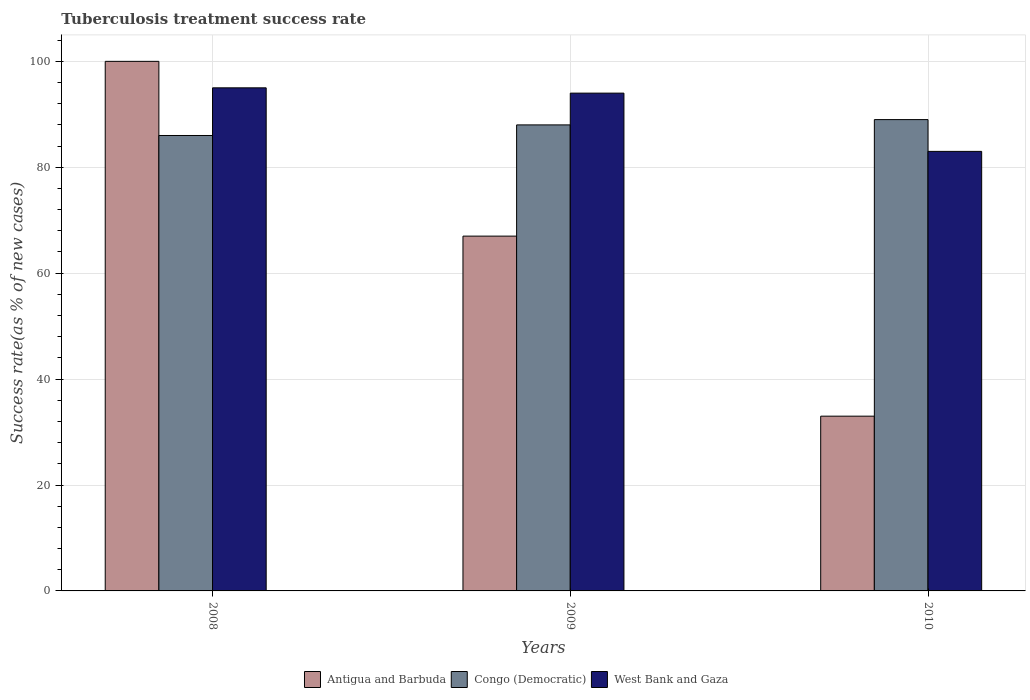How many different coloured bars are there?
Make the answer very short. 3. How many groups of bars are there?
Your response must be concise. 3. How many bars are there on the 2nd tick from the right?
Your response must be concise. 3. What is the tuberculosis treatment success rate in Antigua and Barbuda in 2008?
Give a very brief answer. 100. Across all years, what is the maximum tuberculosis treatment success rate in West Bank and Gaza?
Make the answer very short. 95. In which year was the tuberculosis treatment success rate in West Bank and Gaza maximum?
Ensure brevity in your answer.  2008. What is the total tuberculosis treatment success rate in West Bank and Gaza in the graph?
Keep it short and to the point. 272. What is the difference between the tuberculosis treatment success rate in West Bank and Gaza in 2008 and the tuberculosis treatment success rate in Congo (Democratic) in 2010?
Offer a terse response. 6. What is the average tuberculosis treatment success rate in Congo (Democratic) per year?
Provide a short and direct response. 87.67. In the year 2009, what is the difference between the tuberculosis treatment success rate in Antigua and Barbuda and tuberculosis treatment success rate in Congo (Democratic)?
Make the answer very short. -21. In how many years, is the tuberculosis treatment success rate in Congo (Democratic) greater than 76 %?
Keep it short and to the point. 3. What is the ratio of the tuberculosis treatment success rate in West Bank and Gaza in 2009 to that in 2010?
Keep it short and to the point. 1.13. Is the tuberculosis treatment success rate in Congo (Democratic) in 2008 less than that in 2010?
Give a very brief answer. Yes. Is the difference between the tuberculosis treatment success rate in Antigua and Barbuda in 2009 and 2010 greater than the difference between the tuberculosis treatment success rate in Congo (Democratic) in 2009 and 2010?
Keep it short and to the point. Yes. What is the difference between the highest and the second highest tuberculosis treatment success rate in West Bank and Gaza?
Give a very brief answer. 1. What is the difference between the highest and the lowest tuberculosis treatment success rate in Congo (Democratic)?
Keep it short and to the point. 3. Is the sum of the tuberculosis treatment success rate in West Bank and Gaza in 2008 and 2010 greater than the maximum tuberculosis treatment success rate in Antigua and Barbuda across all years?
Make the answer very short. Yes. What does the 1st bar from the left in 2009 represents?
Your response must be concise. Antigua and Barbuda. What does the 1st bar from the right in 2010 represents?
Your answer should be compact. West Bank and Gaza. Are all the bars in the graph horizontal?
Offer a very short reply. No. What is the difference between two consecutive major ticks on the Y-axis?
Your response must be concise. 20. Are the values on the major ticks of Y-axis written in scientific E-notation?
Offer a very short reply. No. Where does the legend appear in the graph?
Offer a terse response. Bottom center. What is the title of the graph?
Keep it short and to the point. Tuberculosis treatment success rate. What is the label or title of the X-axis?
Offer a terse response. Years. What is the label or title of the Y-axis?
Ensure brevity in your answer.  Success rate(as % of new cases). What is the Success rate(as % of new cases) in Antigua and Barbuda in 2008?
Give a very brief answer. 100. What is the Success rate(as % of new cases) of Congo (Democratic) in 2008?
Offer a very short reply. 86. What is the Success rate(as % of new cases) in Congo (Democratic) in 2009?
Provide a succinct answer. 88. What is the Success rate(as % of new cases) of West Bank and Gaza in 2009?
Offer a very short reply. 94. What is the Success rate(as % of new cases) of Congo (Democratic) in 2010?
Your response must be concise. 89. What is the Success rate(as % of new cases) of West Bank and Gaza in 2010?
Your response must be concise. 83. Across all years, what is the maximum Success rate(as % of new cases) of Congo (Democratic)?
Ensure brevity in your answer.  89. Across all years, what is the maximum Success rate(as % of new cases) of West Bank and Gaza?
Provide a short and direct response. 95. Across all years, what is the minimum Success rate(as % of new cases) of Congo (Democratic)?
Give a very brief answer. 86. Across all years, what is the minimum Success rate(as % of new cases) of West Bank and Gaza?
Provide a short and direct response. 83. What is the total Success rate(as % of new cases) in Congo (Democratic) in the graph?
Give a very brief answer. 263. What is the total Success rate(as % of new cases) of West Bank and Gaza in the graph?
Give a very brief answer. 272. What is the difference between the Success rate(as % of new cases) in West Bank and Gaza in 2008 and that in 2010?
Provide a succinct answer. 12. What is the difference between the Success rate(as % of new cases) of Antigua and Barbuda in 2009 and that in 2010?
Offer a terse response. 34. What is the difference between the Success rate(as % of new cases) in West Bank and Gaza in 2009 and that in 2010?
Keep it short and to the point. 11. What is the difference between the Success rate(as % of new cases) of Antigua and Barbuda in 2008 and the Success rate(as % of new cases) of West Bank and Gaza in 2009?
Your answer should be very brief. 6. What is the difference between the Success rate(as % of new cases) in Congo (Democratic) in 2008 and the Success rate(as % of new cases) in West Bank and Gaza in 2009?
Give a very brief answer. -8. What is the difference between the Success rate(as % of new cases) in Antigua and Barbuda in 2008 and the Success rate(as % of new cases) in Congo (Democratic) in 2010?
Give a very brief answer. 11. What is the difference between the Success rate(as % of new cases) in Congo (Democratic) in 2008 and the Success rate(as % of new cases) in West Bank and Gaza in 2010?
Make the answer very short. 3. What is the difference between the Success rate(as % of new cases) in Antigua and Barbuda in 2009 and the Success rate(as % of new cases) in Congo (Democratic) in 2010?
Your answer should be very brief. -22. What is the difference between the Success rate(as % of new cases) in Antigua and Barbuda in 2009 and the Success rate(as % of new cases) in West Bank and Gaza in 2010?
Give a very brief answer. -16. What is the difference between the Success rate(as % of new cases) of Congo (Democratic) in 2009 and the Success rate(as % of new cases) of West Bank and Gaza in 2010?
Provide a short and direct response. 5. What is the average Success rate(as % of new cases) of Antigua and Barbuda per year?
Offer a very short reply. 66.67. What is the average Success rate(as % of new cases) of Congo (Democratic) per year?
Your response must be concise. 87.67. What is the average Success rate(as % of new cases) in West Bank and Gaza per year?
Make the answer very short. 90.67. In the year 2008, what is the difference between the Success rate(as % of new cases) of Antigua and Barbuda and Success rate(as % of new cases) of Congo (Democratic)?
Keep it short and to the point. 14. In the year 2008, what is the difference between the Success rate(as % of new cases) of Antigua and Barbuda and Success rate(as % of new cases) of West Bank and Gaza?
Give a very brief answer. 5. In the year 2009, what is the difference between the Success rate(as % of new cases) in Antigua and Barbuda and Success rate(as % of new cases) in West Bank and Gaza?
Your response must be concise. -27. In the year 2009, what is the difference between the Success rate(as % of new cases) of Congo (Democratic) and Success rate(as % of new cases) of West Bank and Gaza?
Your answer should be very brief. -6. In the year 2010, what is the difference between the Success rate(as % of new cases) of Antigua and Barbuda and Success rate(as % of new cases) of Congo (Democratic)?
Make the answer very short. -56. In the year 2010, what is the difference between the Success rate(as % of new cases) in Antigua and Barbuda and Success rate(as % of new cases) in West Bank and Gaza?
Ensure brevity in your answer.  -50. In the year 2010, what is the difference between the Success rate(as % of new cases) in Congo (Democratic) and Success rate(as % of new cases) in West Bank and Gaza?
Your answer should be compact. 6. What is the ratio of the Success rate(as % of new cases) in Antigua and Barbuda in 2008 to that in 2009?
Keep it short and to the point. 1.49. What is the ratio of the Success rate(as % of new cases) in Congo (Democratic) in 2008 to that in 2009?
Your response must be concise. 0.98. What is the ratio of the Success rate(as % of new cases) in West Bank and Gaza in 2008 to that in 2009?
Offer a very short reply. 1.01. What is the ratio of the Success rate(as % of new cases) in Antigua and Barbuda in 2008 to that in 2010?
Provide a short and direct response. 3.03. What is the ratio of the Success rate(as % of new cases) in Congo (Democratic) in 2008 to that in 2010?
Ensure brevity in your answer.  0.97. What is the ratio of the Success rate(as % of new cases) in West Bank and Gaza in 2008 to that in 2010?
Ensure brevity in your answer.  1.14. What is the ratio of the Success rate(as % of new cases) in Antigua and Barbuda in 2009 to that in 2010?
Ensure brevity in your answer.  2.03. What is the ratio of the Success rate(as % of new cases) in West Bank and Gaza in 2009 to that in 2010?
Give a very brief answer. 1.13. What is the difference between the highest and the second highest Success rate(as % of new cases) of Antigua and Barbuda?
Offer a very short reply. 33. What is the difference between the highest and the second highest Success rate(as % of new cases) of Congo (Democratic)?
Your answer should be very brief. 1. What is the difference between the highest and the lowest Success rate(as % of new cases) of Antigua and Barbuda?
Make the answer very short. 67. What is the difference between the highest and the lowest Success rate(as % of new cases) of Congo (Democratic)?
Provide a succinct answer. 3. 